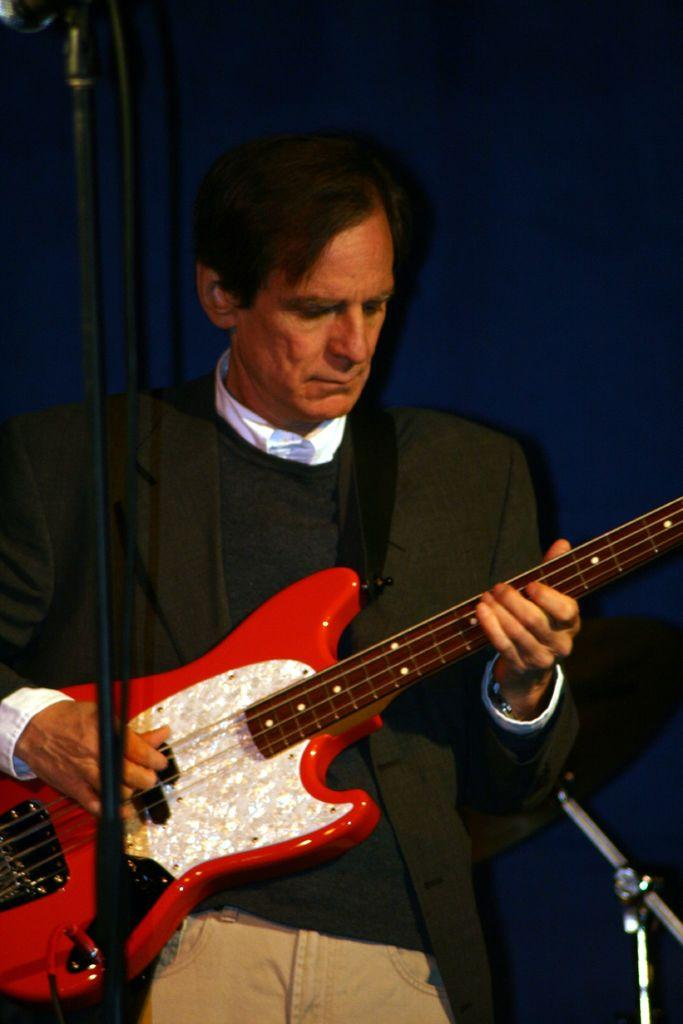What is the man in the image doing? The man is playing a guitar. What object is the man using to create music? The man is using a guitar to create music. What can be seen in the background of the image? There is a blue curtain in the background of the image. What type of grape is the man holding in the image? There is no grape present in the image; the man is playing a guitar. 